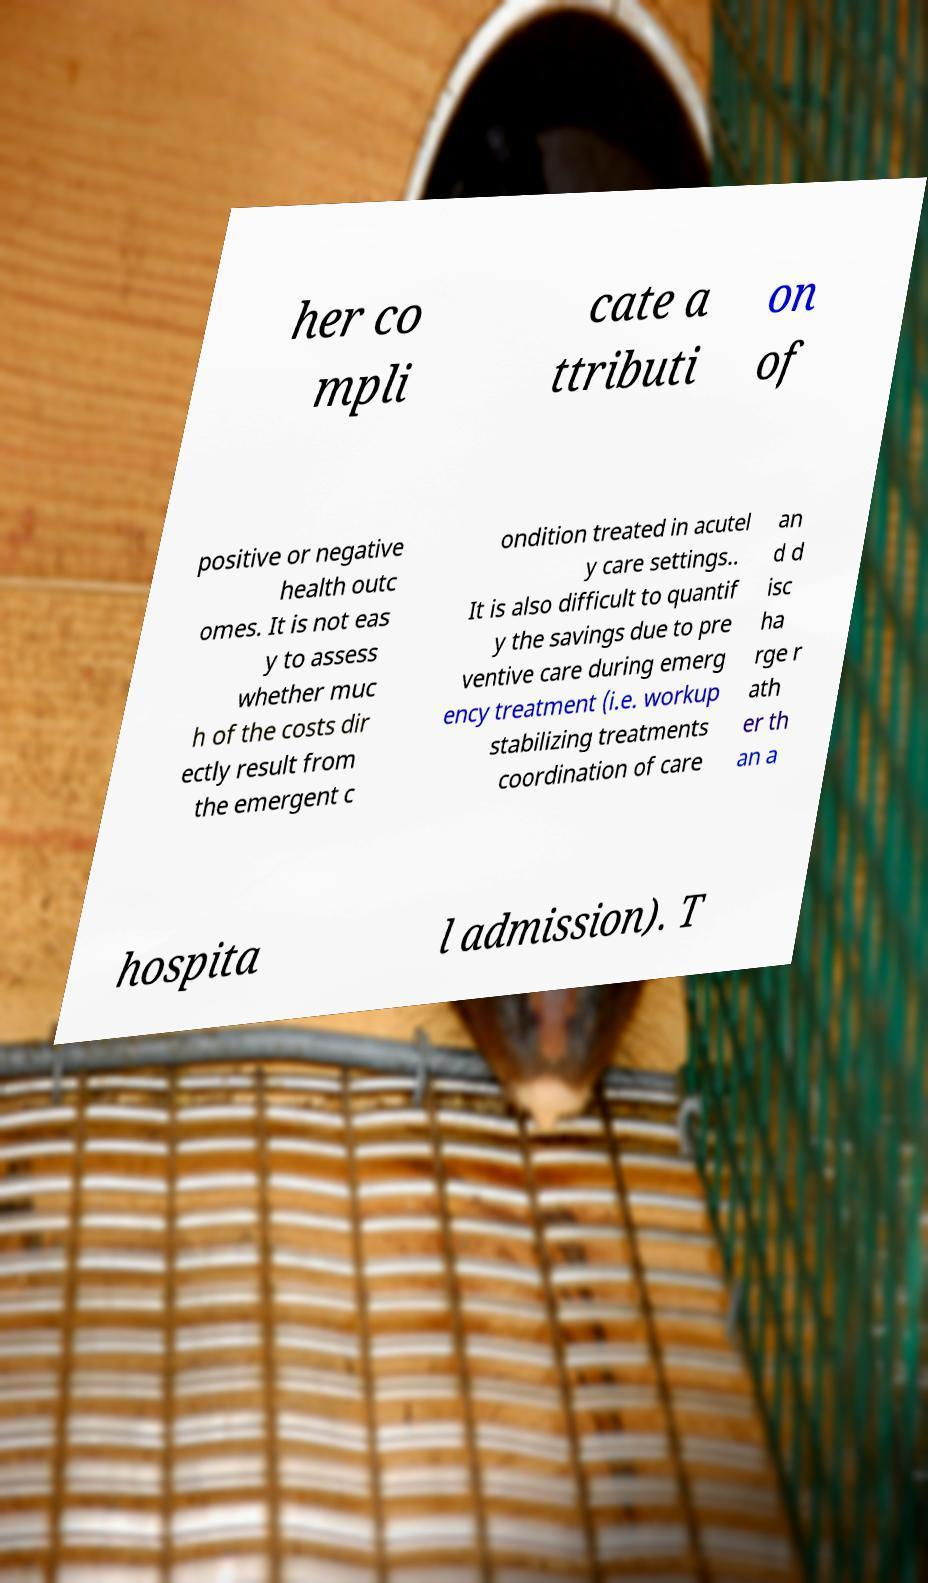What messages or text are displayed in this image? I need them in a readable, typed format. her co mpli cate a ttributi on of positive or negative health outc omes. It is not eas y to assess whether muc h of the costs dir ectly result from the emergent c ondition treated in acutel y care settings.. It is also difficult to quantif y the savings due to pre ventive care during emerg ency treatment (i.e. workup stabilizing treatments coordination of care an d d isc ha rge r ath er th an a hospita l admission). T 